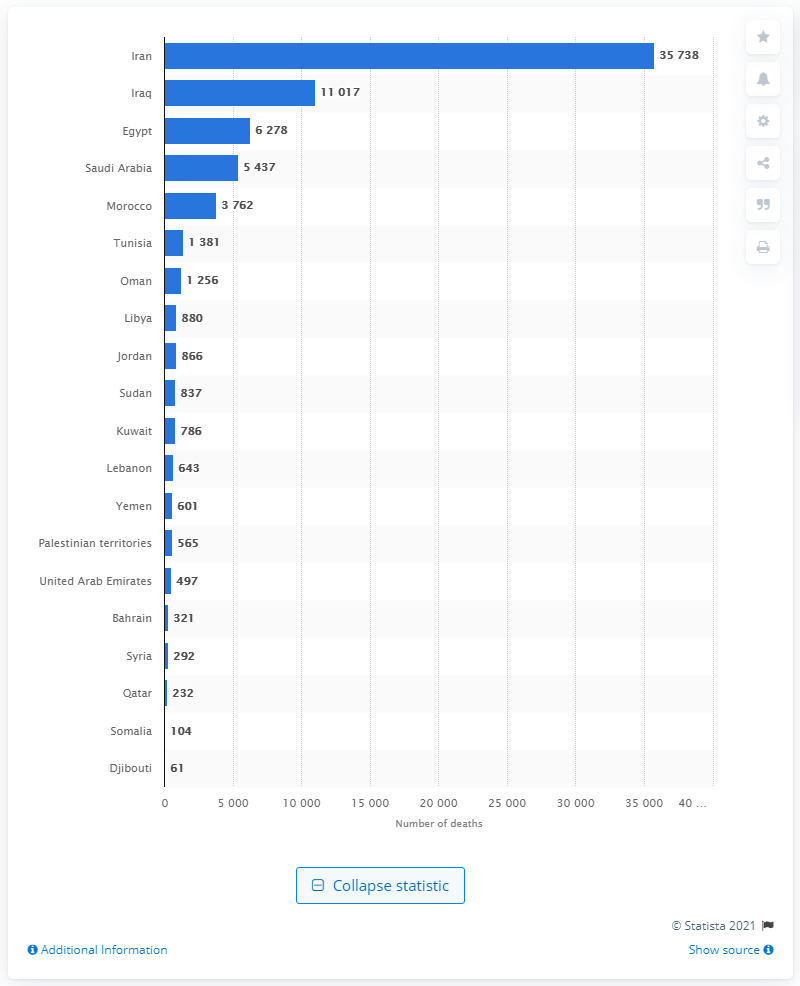Identify some key points in this picture. As of November 3, 2020, COVID-19 had caused a reported 35,738 deaths in Iran. 